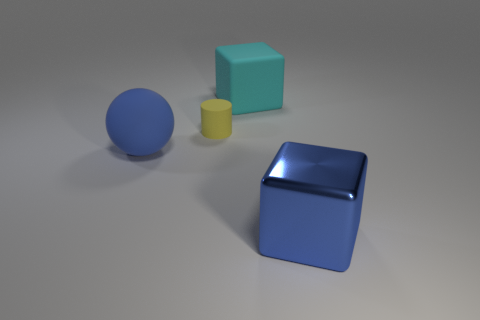Subtract all spheres. How many objects are left? 3 Add 2 cyan things. How many objects exist? 6 Subtract 0 gray cylinders. How many objects are left? 4 Subtract all red cylinders. Subtract all blue spheres. How many cylinders are left? 1 Subtract all brown spheres. How many blue blocks are left? 1 Subtract all large blue spheres. Subtract all purple spheres. How many objects are left? 3 Add 1 blocks. How many blocks are left? 3 Add 2 tiny cyan shiny cylinders. How many tiny cyan shiny cylinders exist? 2 